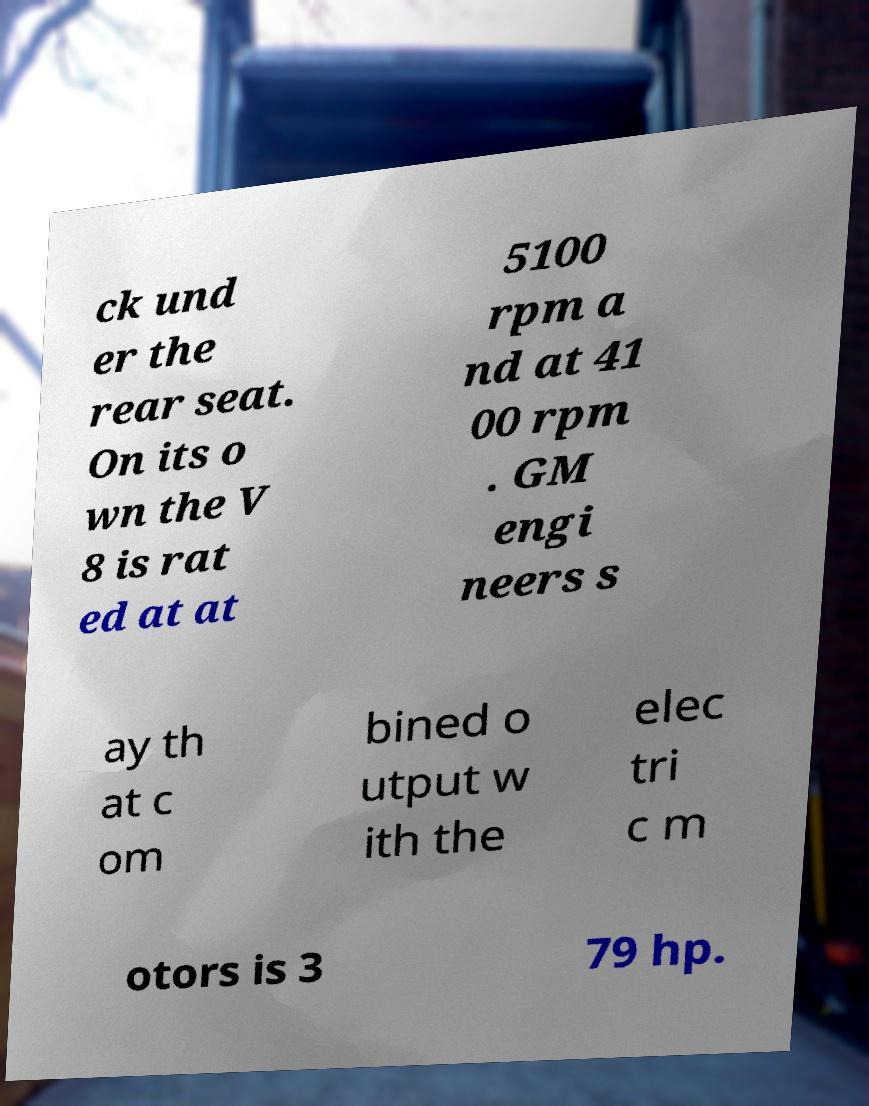Can you accurately transcribe the text from the provided image for me? ck und er the rear seat. On its o wn the V 8 is rat ed at at 5100 rpm a nd at 41 00 rpm . GM engi neers s ay th at c om bined o utput w ith the elec tri c m otors is 3 79 hp. 